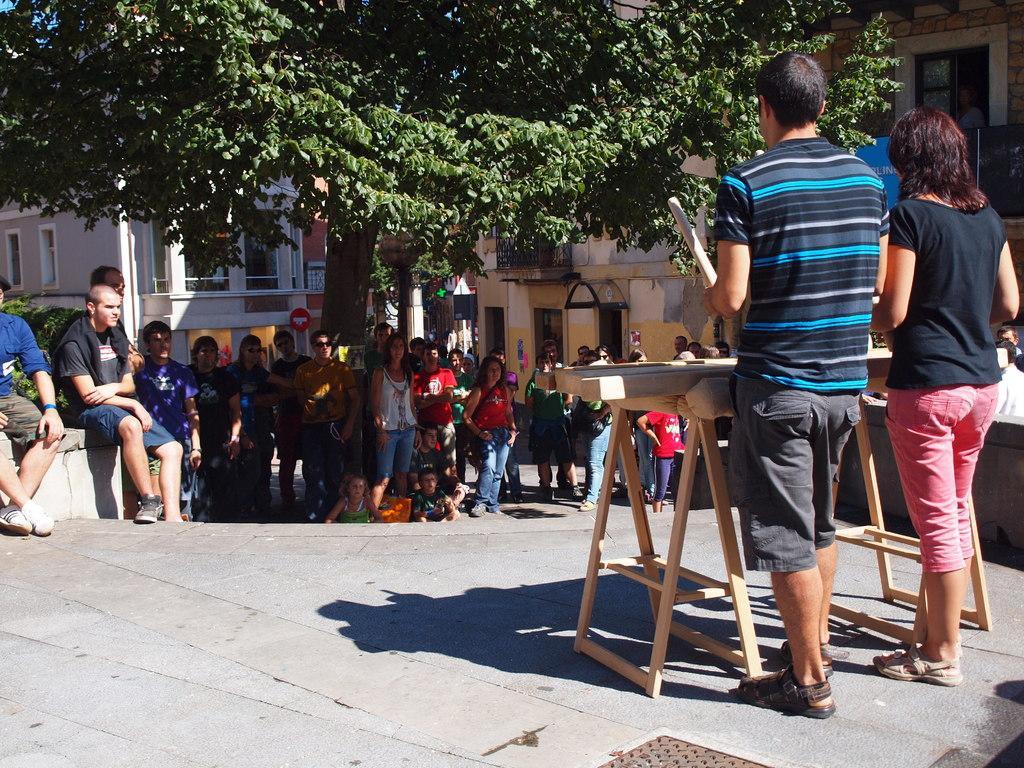Could you give a brief overview of what you see in this image? In this image in the foreground there are two persons who are standing, and in front of them there is one wooden table and also in the center there are some people who are standing and some of them are sitting. And in the background there are some houses and trees, at the bottom there is a walkway. 